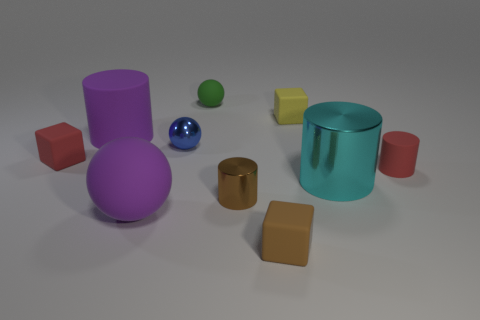What number of other things are the same shape as the green thing?
Offer a terse response. 2. Is the purple cylinder the same size as the cyan thing?
Make the answer very short. Yes. There is another small matte object that is the same shape as the blue thing; what is its color?
Your answer should be compact. Green. How many other cylinders have the same color as the small matte cylinder?
Your answer should be compact. 0. Is the number of small brown cubes that are to the left of the tiny brown rubber object greater than the number of tiny yellow rubber objects?
Give a very brief answer. No. What is the color of the tiny rubber thing right of the rubber cube behind the tiny blue object?
Make the answer very short. Red. How many things are either red things that are on the left side of the tiny brown matte object or tiny red things that are left of the tiny yellow cube?
Offer a very short reply. 1. The tiny metal cylinder has what color?
Make the answer very short. Brown. What number of tiny objects have the same material as the small green sphere?
Give a very brief answer. 4. Are there more tiny red rubber cylinders than matte cylinders?
Provide a short and direct response. No. 